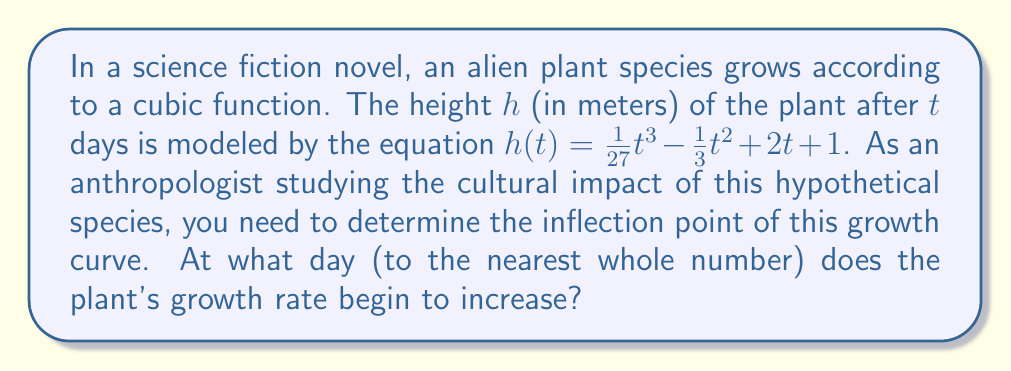Can you solve this math problem? To find the inflection point, we need to follow these steps:

1) The inflection point occurs where the second derivative of the function equals zero. Let's start by finding the first and second derivatives.

2) First derivative:
   $$h'(t) = \frac{1}{9}t^2 - \frac{2}{3}t + 2$$

3) Second derivative:
   $$h''(t) = \frac{2}{9}t - \frac{2}{3}$$

4) Set the second derivative equal to zero and solve for t:
   $$\frac{2}{9}t - \frac{2}{3} = 0$$
   $$\frac{2}{9}t = \frac{2}{3}$$
   $$t = 3$$

5) To confirm this is an inflection point, we can check that h''(t) changes sign at t = 3:
   For t < 3, h''(t) < 0
   For t > 3, h''(t) > 0

6) Therefore, the inflection point occurs at t = 3 days.

This inflection point represents the day when the plant's growth rate begins to increase, which could be a significant moment in the plant's life cycle and potentially impact the alien culture's interaction with or perception of the plant.
Answer: 3 days 